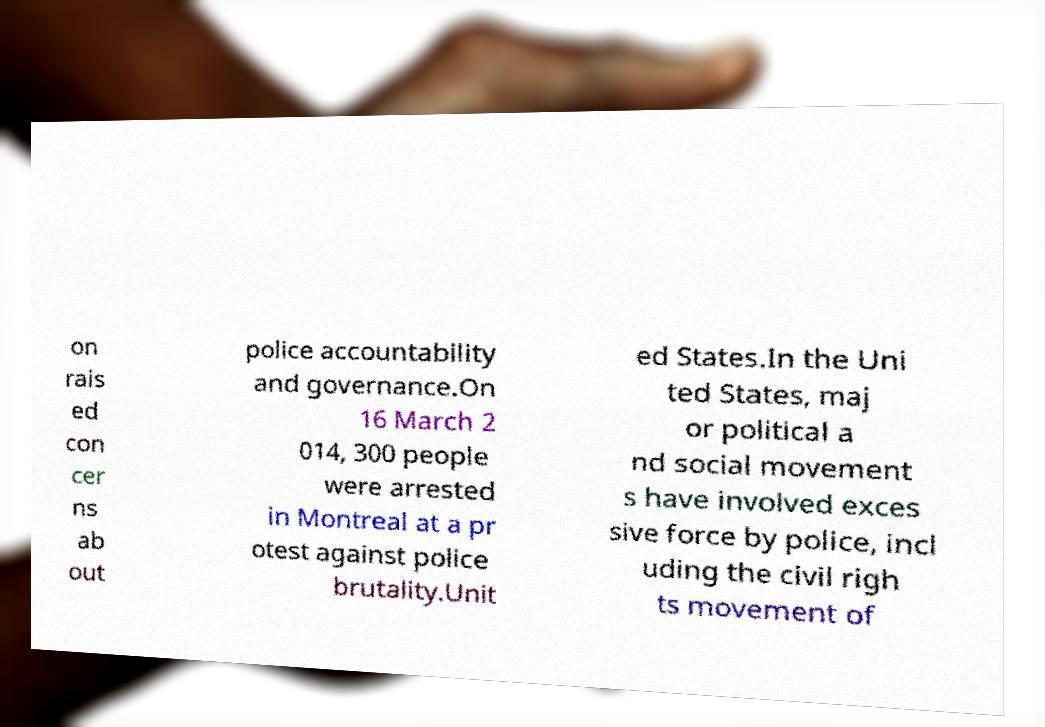Can you accurately transcribe the text from the provided image for me? on rais ed con cer ns ab out police accountability and governance.On 16 March 2 014, 300 people were arrested in Montreal at a pr otest against police brutality.Unit ed States.In the Uni ted States, maj or political a nd social movement s have involved exces sive force by police, incl uding the civil righ ts movement of 